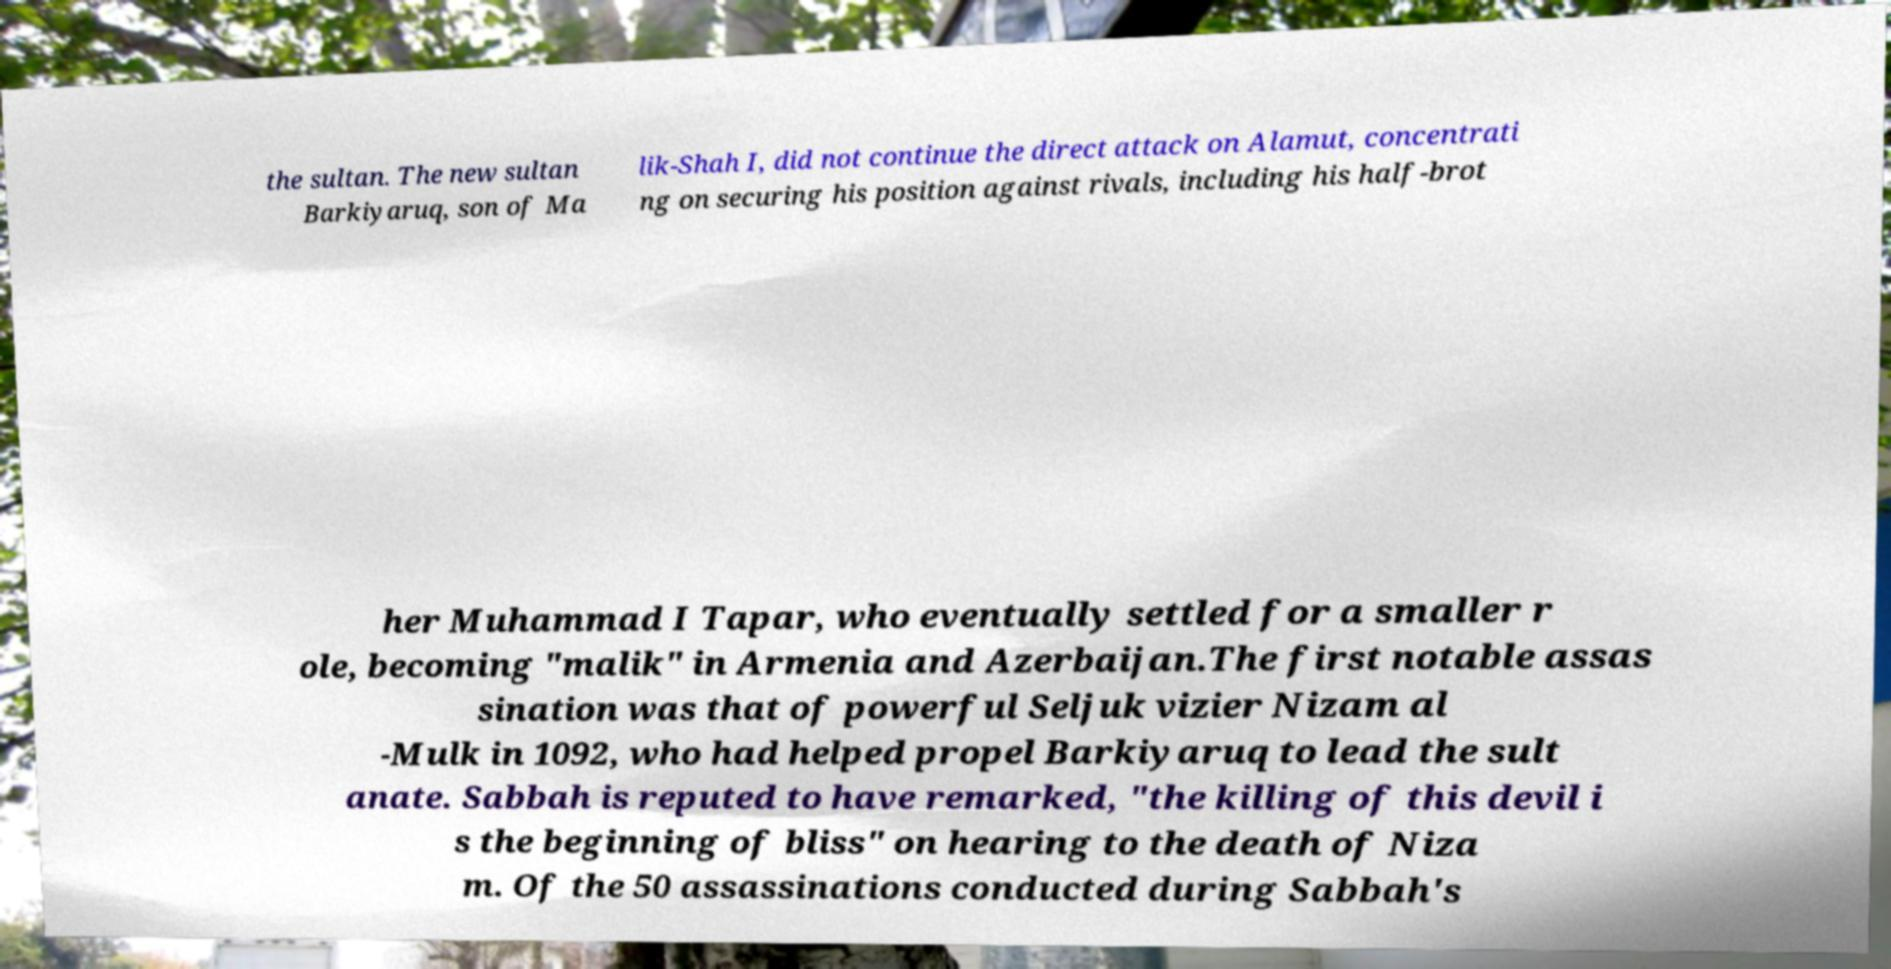I need the written content from this picture converted into text. Can you do that? the sultan. The new sultan Barkiyaruq, son of Ma lik-Shah I, did not continue the direct attack on Alamut, concentrati ng on securing his position against rivals, including his half-brot her Muhammad I Tapar, who eventually settled for a smaller r ole, becoming "malik" in Armenia and Azerbaijan.The first notable assas sination was that of powerful Seljuk vizier Nizam al -Mulk in 1092, who had helped propel Barkiyaruq to lead the sult anate. Sabbah is reputed to have remarked, "the killing of this devil i s the beginning of bliss" on hearing to the death of Niza m. Of the 50 assassinations conducted during Sabbah's 